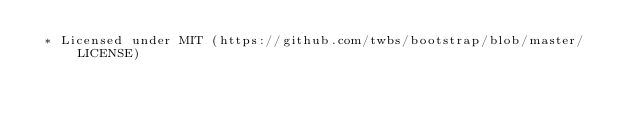<code> <loc_0><loc_0><loc_500><loc_500><_CSS_> * Licensed under MIT (https://github.com/twbs/bootstrap/blob/master/LICENSE)</code> 